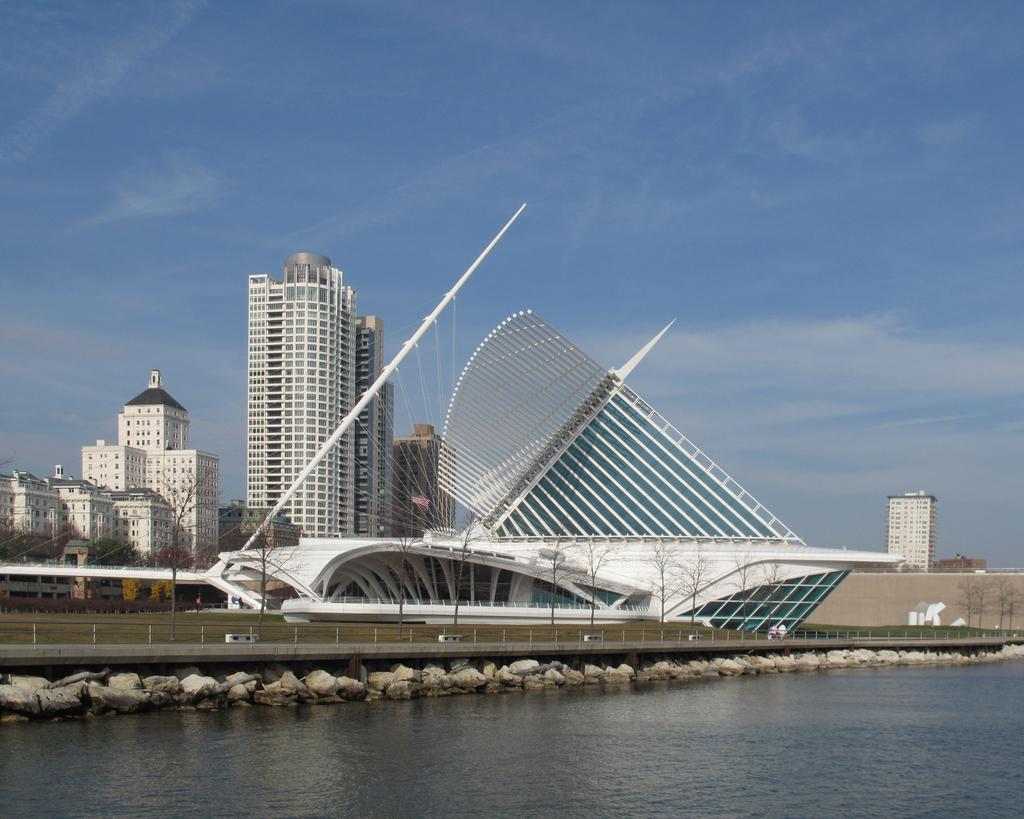Can you describe this image briefly? In this image I can see there are water and stones. And there are persons on the bridge. And there are grass and buildings. And there are trees. And at the top there is a sky. 